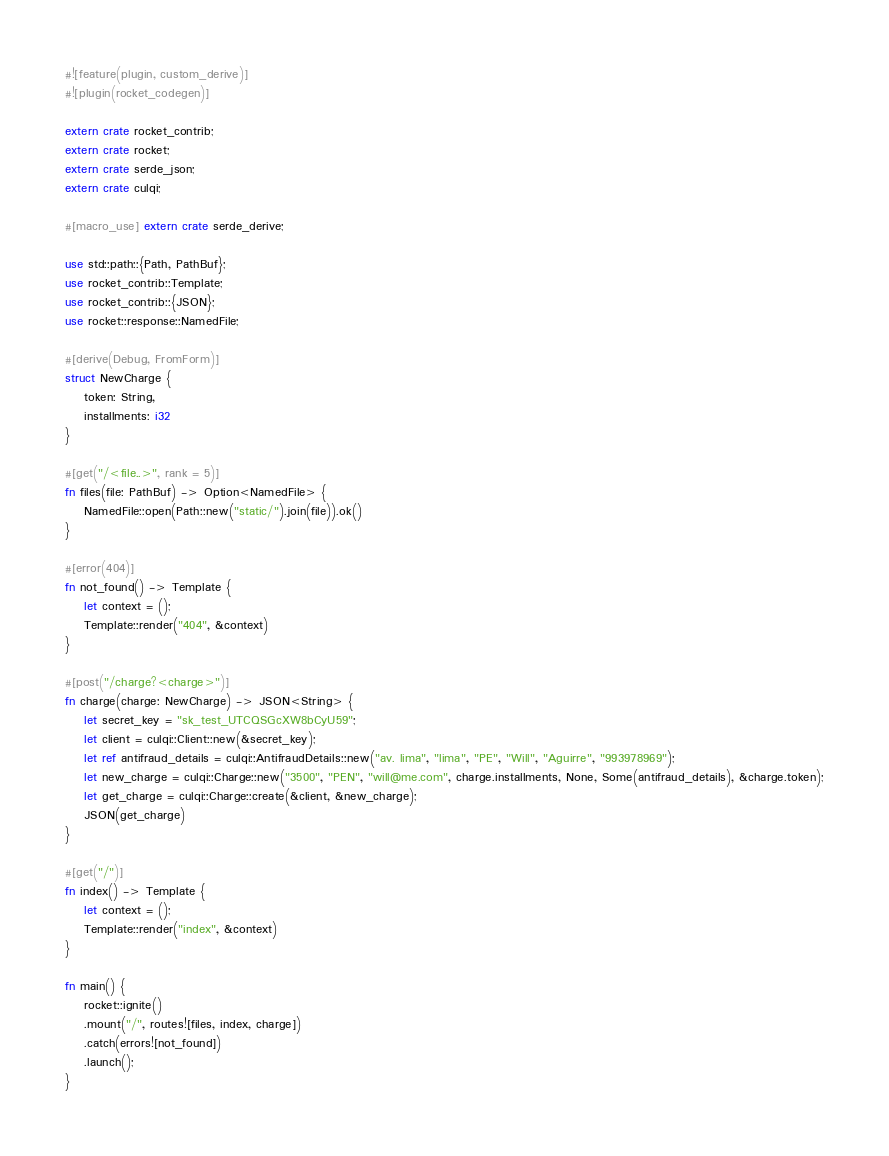Convert code to text. <code><loc_0><loc_0><loc_500><loc_500><_Rust_>#![feature(plugin, custom_derive)]
#![plugin(rocket_codegen)]

extern crate rocket_contrib;
extern crate rocket;
extern crate serde_json;
extern crate culqi;

#[macro_use] extern crate serde_derive;

use std::path::{Path, PathBuf};
use rocket_contrib::Template;
use rocket_contrib::{JSON};
use rocket::response::NamedFile;

#[derive(Debug, FromForm)]
struct NewCharge {
    token: String,
    installments: i32
}

#[get("/<file..>", rank = 5)]
fn files(file: PathBuf) -> Option<NamedFile> {
    NamedFile::open(Path::new("static/").join(file)).ok()
}

#[error(404)]
fn not_found() -> Template {
    let context = ();
    Template::render("404", &context)
}

#[post("/charge?<charge>")]
fn charge(charge: NewCharge) -> JSON<String> {
    let secret_key = "sk_test_UTCQSGcXW8bCyU59";
    let client = culqi::Client::new(&secret_key);
    let ref antifraud_details = culqi::AntifraudDetails::new("av. lima", "lima", "PE", "Will", "Aguirre", "993978969");
    let new_charge = culqi::Charge::new("3500", "PEN", "will@me.com", charge.installments, None, Some(antifraud_details), &charge.token);
    let get_charge = culqi::Charge::create(&client, &new_charge);
    JSON(get_charge)
}

#[get("/")]
fn index() -> Template {
    let context = ();
    Template::render("index", &context)
}

fn main() {
    rocket::ignite()
    .mount("/", routes![files, index, charge])
    .catch(errors![not_found])
    .launch();
}
</code> 